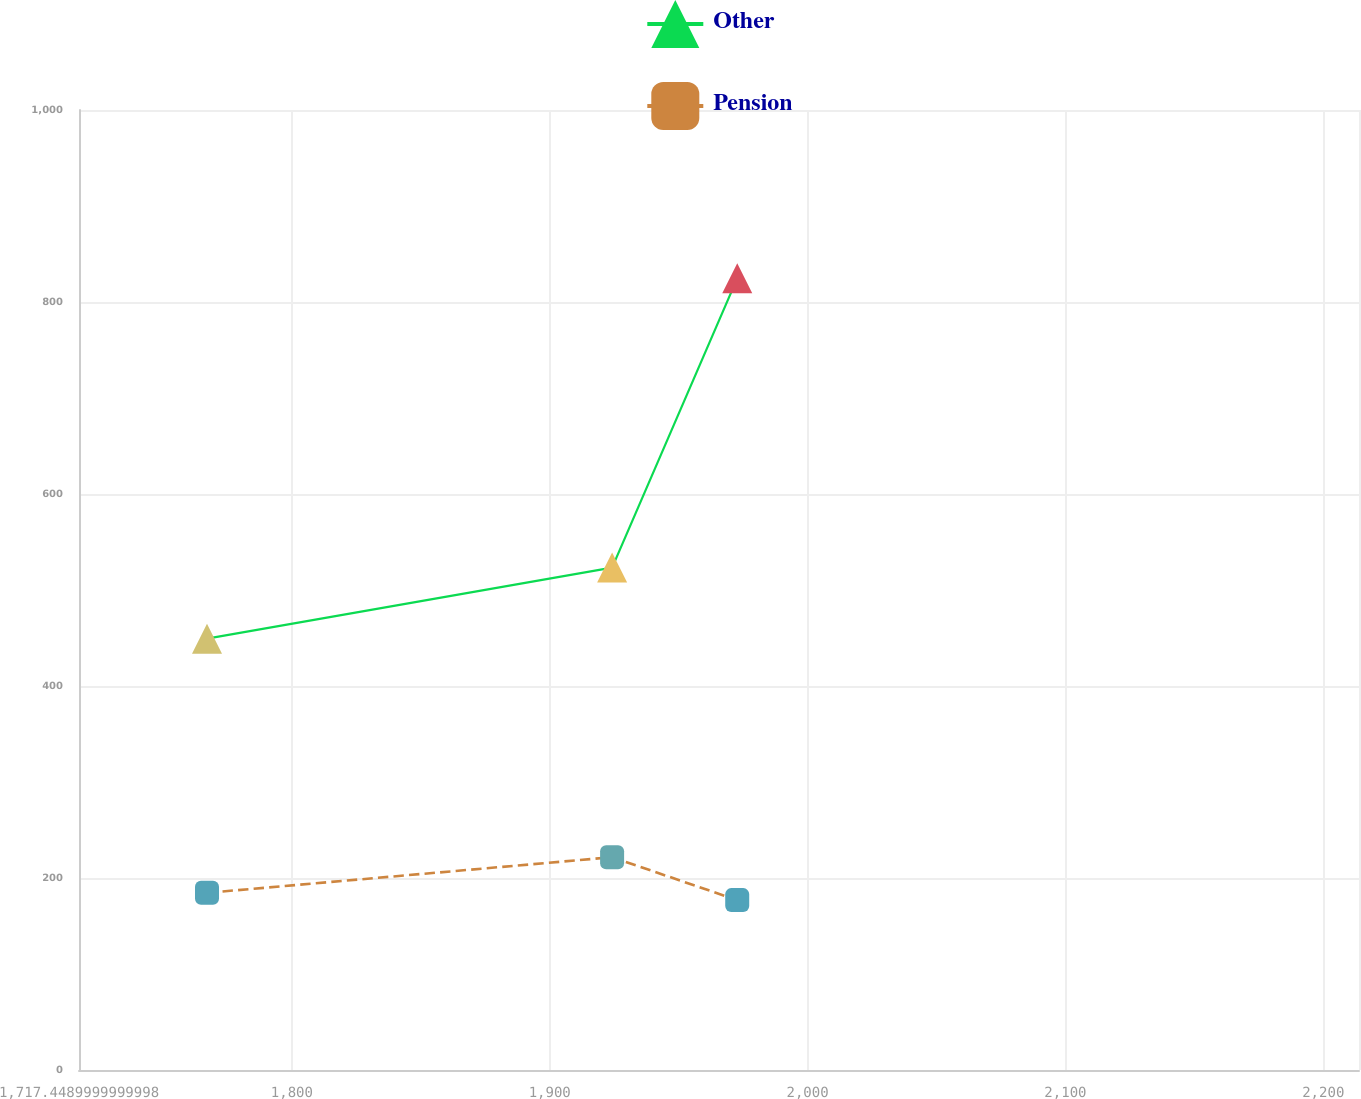Convert chart to OTSL. <chart><loc_0><loc_0><loc_500><loc_500><line_chart><ecel><fcel>Other<fcel>Pension<nl><fcel>1767.09<fcel>449.27<fcel>184.53<nl><fcel>1924.2<fcel>523.37<fcel>221.67<nl><fcel>1972.72<fcel>824.67<fcel>176.96<nl><fcel>2214.98<fcel>638.12<fcel>209.9<nl><fcel>2263.5<fcel>560.91<fcel>252.63<nl></chart> 